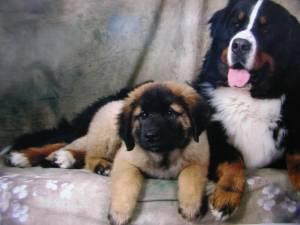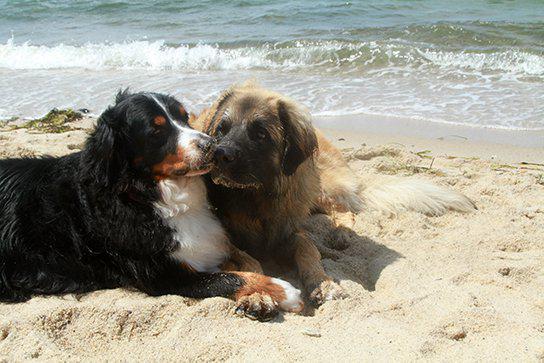The first image is the image on the left, the second image is the image on the right. For the images shown, is this caption "There are exactly two dogs lying in the image on the right." true? Answer yes or no. Yes. 